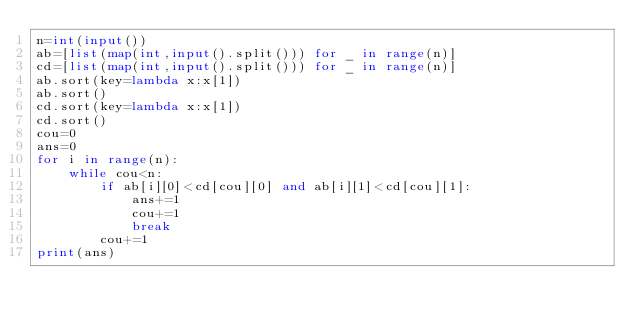<code> <loc_0><loc_0><loc_500><loc_500><_Python_>n=int(input())
ab=[list(map(int,input().split())) for _ in range(n)]
cd=[list(map(int,input().split())) for _ in range(n)]
ab.sort(key=lambda x:x[1])
ab.sort()
cd.sort(key=lambda x:x[1])
cd.sort()
cou=0
ans=0
for i in range(n):
    while cou<n:
        if ab[i][0]<cd[cou][0] and ab[i][1]<cd[cou][1]:
            ans+=1
            cou+=1
            break
        cou+=1
print(ans)
</code> 